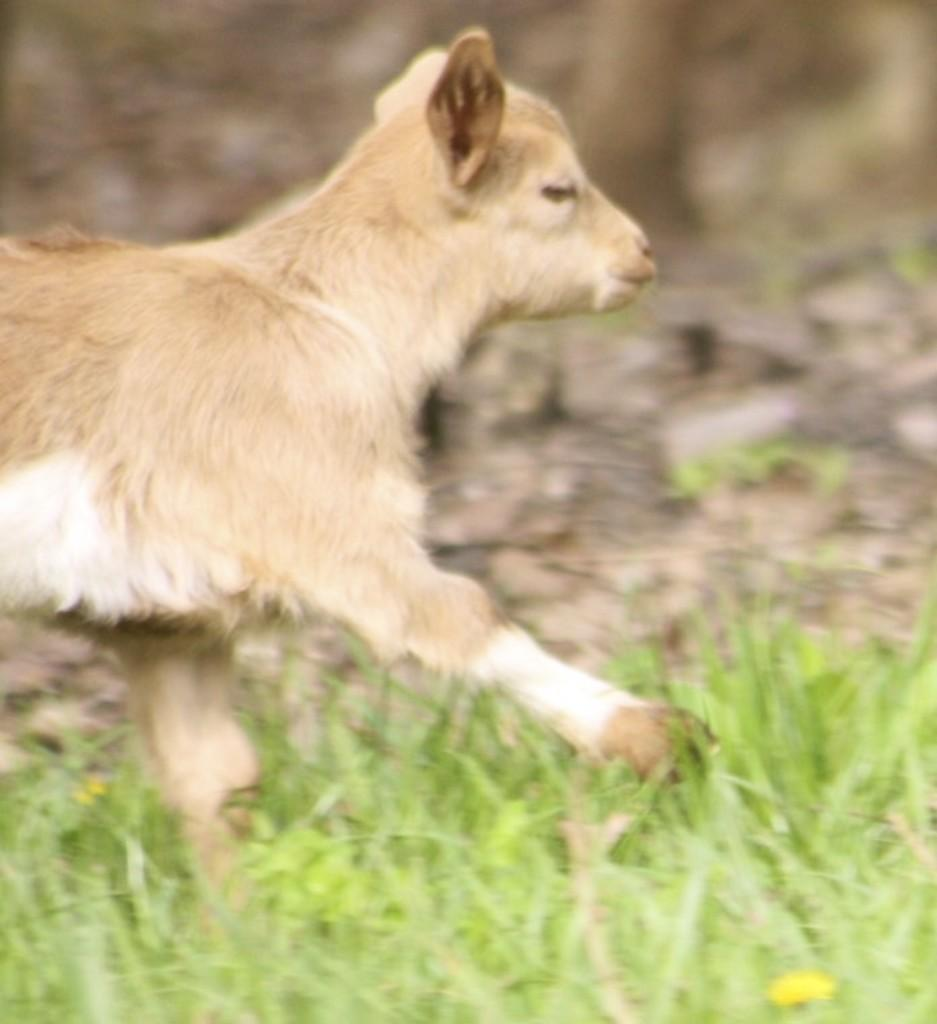What type of creature can be seen in the image? There is an animal in the image. Where is the animal located? The animal is on the grass. What type of footwear is the animal wearing in the image? There is no footwear present in the image, as animals do not typically wear footwear. 